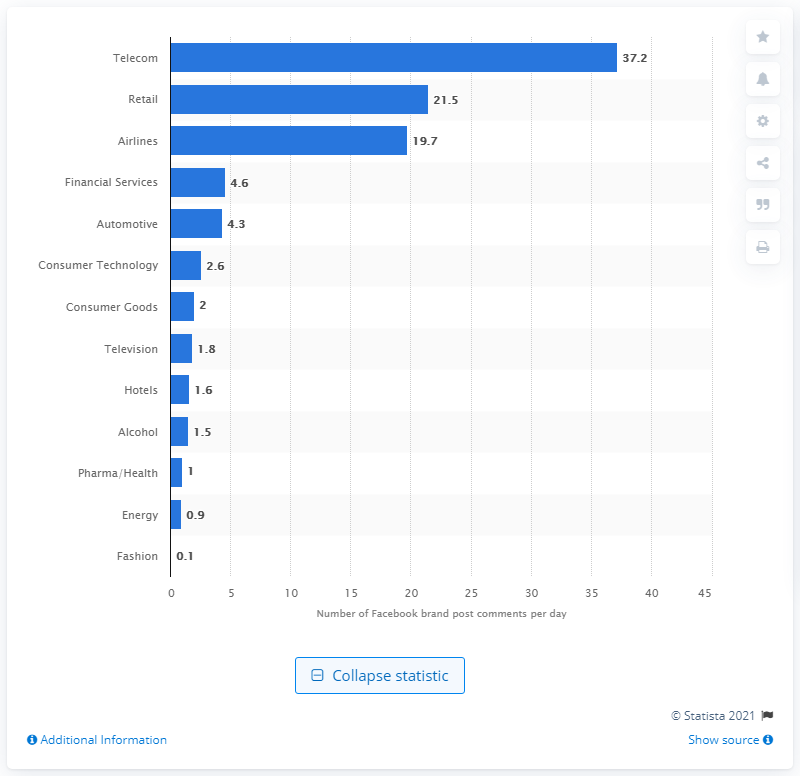Point out several critical features in this image. The average number of comments per brand post is 2.6. 